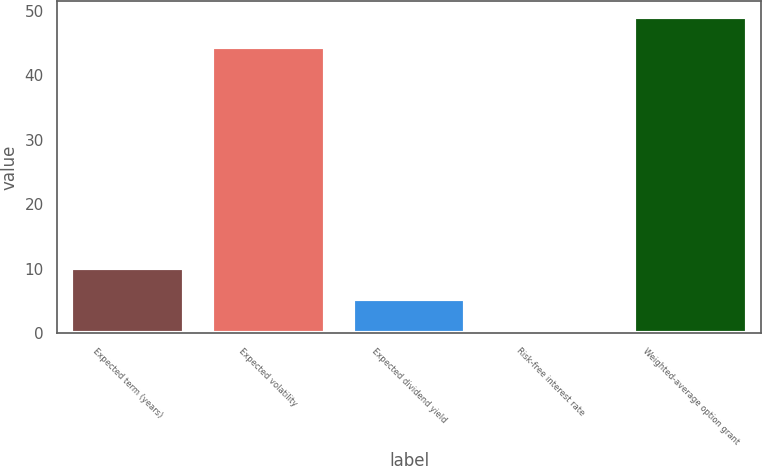<chart> <loc_0><loc_0><loc_500><loc_500><bar_chart><fcel>Expected term (years)<fcel>Expected volatility<fcel>Expected dividend yield<fcel>Risk-free interest rate<fcel>Weighted-average option grant<nl><fcel>10.06<fcel>44.3<fcel>5.33<fcel>0.6<fcel>49.03<nl></chart> 